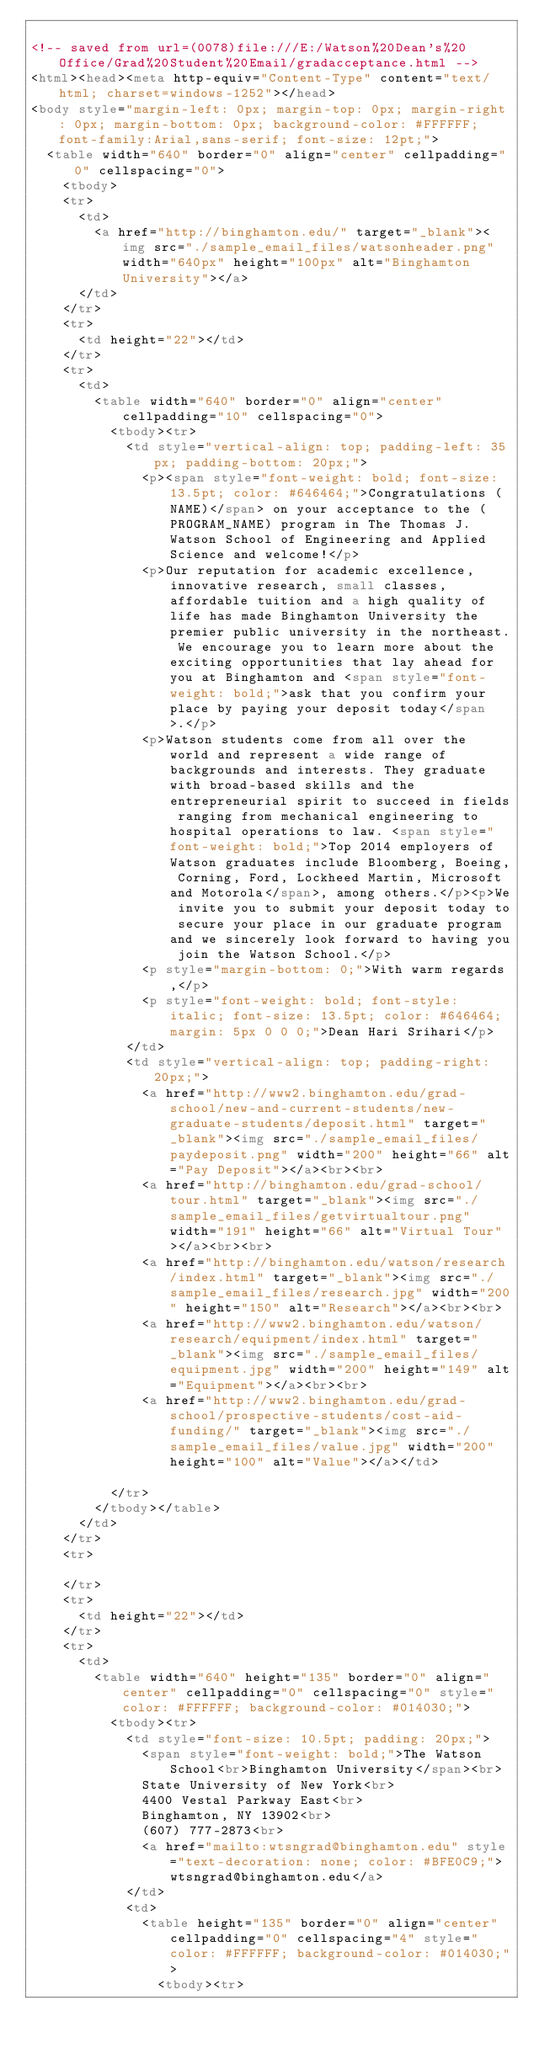Convert code to text. <code><loc_0><loc_0><loc_500><loc_500><_HTML_>
<!-- saved from url=(0078)file:///E:/Watson%20Dean's%20Office/Grad%20Student%20Email/gradacceptance.html -->
<html><head><meta http-equiv="Content-Type" content="text/html; charset=windows-1252"></head>
<body style="margin-left: 0px; margin-top: 0px; margin-right: 0px; margin-bottom: 0px; background-color: #FFFFFF; font-family:Arial,sans-serif; font-size: 12pt;">
	<table width="640" border="0" align="center" cellpadding="0" cellspacing="0">
		<tbody>
		<tr>
			<td>
				<a href="http://binghamton.edu/" target="_blank"><img src="./sample_email_files/watsonheader.png" width="640px" height="100px" alt="Binghamton University"></a>
			</td>
		</tr>
		<tr>
			<td height="22"></td>
		</tr>
		<tr>
			<td>
				<table width="640" border="0" align="center" cellpadding="10" cellspacing="0">
					<tbody><tr>
						<td style="vertical-align: top; padding-left: 35px; padding-bottom: 20px;">
							<p><span style="font-weight: bold; font-size: 13.5pt; color: #646464;">Congratulations (NAME)</span> on your acceptance to the (PROGRAM_NAME) program in The Thomas J. Watson School of Engineering and Applied Science and welcome!</p>
							<p>Our reputation for academic excellence, innovative research, small classes, affordable tuition and a high quality of life has made Binghamton University the premier public university in the northeast. We encourage you to learn more about the exciting opportunities that lay ahead for you at Binghamton and <span style="font-weight: bold;">ask that you confirm your place by paying your deposit today</span>.</p>
							<p>Watson students come from all over the world and represent a wide range of backgrounds and interests. They graduate with broad-based skills and the entrepreneurial spirit to succeed in fields ranging from mechanical engineering to hospital operations to law. <span style="font-weight: bold;">Top 2014 employers of Watson graduates include Bloomberg, Boeing, Corning, Ford, Lockheed Martin, Microsoft and Motorola</span>, among others.</p><p>We invite you to submit your deposit today to secure your place in our graduate program and we sincerely look forward to having you join the Watson School.</p>
							<p style="margin-bottom: 0;">With warm regards,</p>
							<p style="font-weight: bold; font-style: italic; font-size: 13.5pt; color: #646464; margin: 5px 0 0 0;">Dean Hari Srihari</p>
						</td>
						<td style="vertical-align: top; padding-right: 20px;">
							<a href="http://www2.binghamton.edu/grad-school/new-and-current-students/new-graduate-students/deposit.html" target="_blank"><img src="./sample_email_files/paydeposit.png" width="200" height="66" alt="Pay Deposit"></a><br><br>
							<a href="http://binghamton.edu/grad-school/tour.html" target="_blank"><img src="./sample_email_files/getvirtualtour.png" width="191" height="66" alt="Virtual Tour"></a><br><br>
							<a href="http://binghamton.edu/watson/research/index.html" target="_blank"><img src="./sample_email_files/research.jpg" width="200" height="150" alt="Research"></a><br><br>
							<a href="http://www2.binghamton.edu/watson/research/equipment/index.html" target="_blank"><img src="./sample_email_files/equipment.jpg" width="200" height="149" alt="Equipment"></a><br><br>
							<a href="http://www2.binghamton.edu/grad-school/prospective-students/cost-aid-funding/" target="_blank"><img src="./sample_email_files/value.jpg" width="200" height="100" alt="Value"></a></td>
						
					</tr>
				</tbody></table>
			</td>
		</tr>
		<tr>
			
		</tr>
		<tr>
			<td height="22"></td>
		</tr>
		<tr>
			<td>
				<table width="640" height="135" border="0" align="center" cellpadding="0" cellspacing="0" style="color: #FFFFFF; background-color: #014030;">
					<tbody><tr>
						<td style="font-size: 10.5pt; padding: 20px;">
							<span style="font-weight: bold;">The Watson School<br>Binghamton University</span><br>
							State University of New York<br>
							4400 Vestal Parkway East<br>
							Binghamton, NY 13902<br>
							(607) 777-2873<br>
							<a href="mailto:wtsngrad@binghamton.edu" style="text-decoration: none; color: #BFE0C9;">wtsngrad@binghamton.edu</a>
						</td>
						<td>
							<table height="135" border="0" align="center" cellpadding="0" cellspacing="4" style="color: #FFFFFF; background-color: #014030;">
								<tbody><tr></code> 